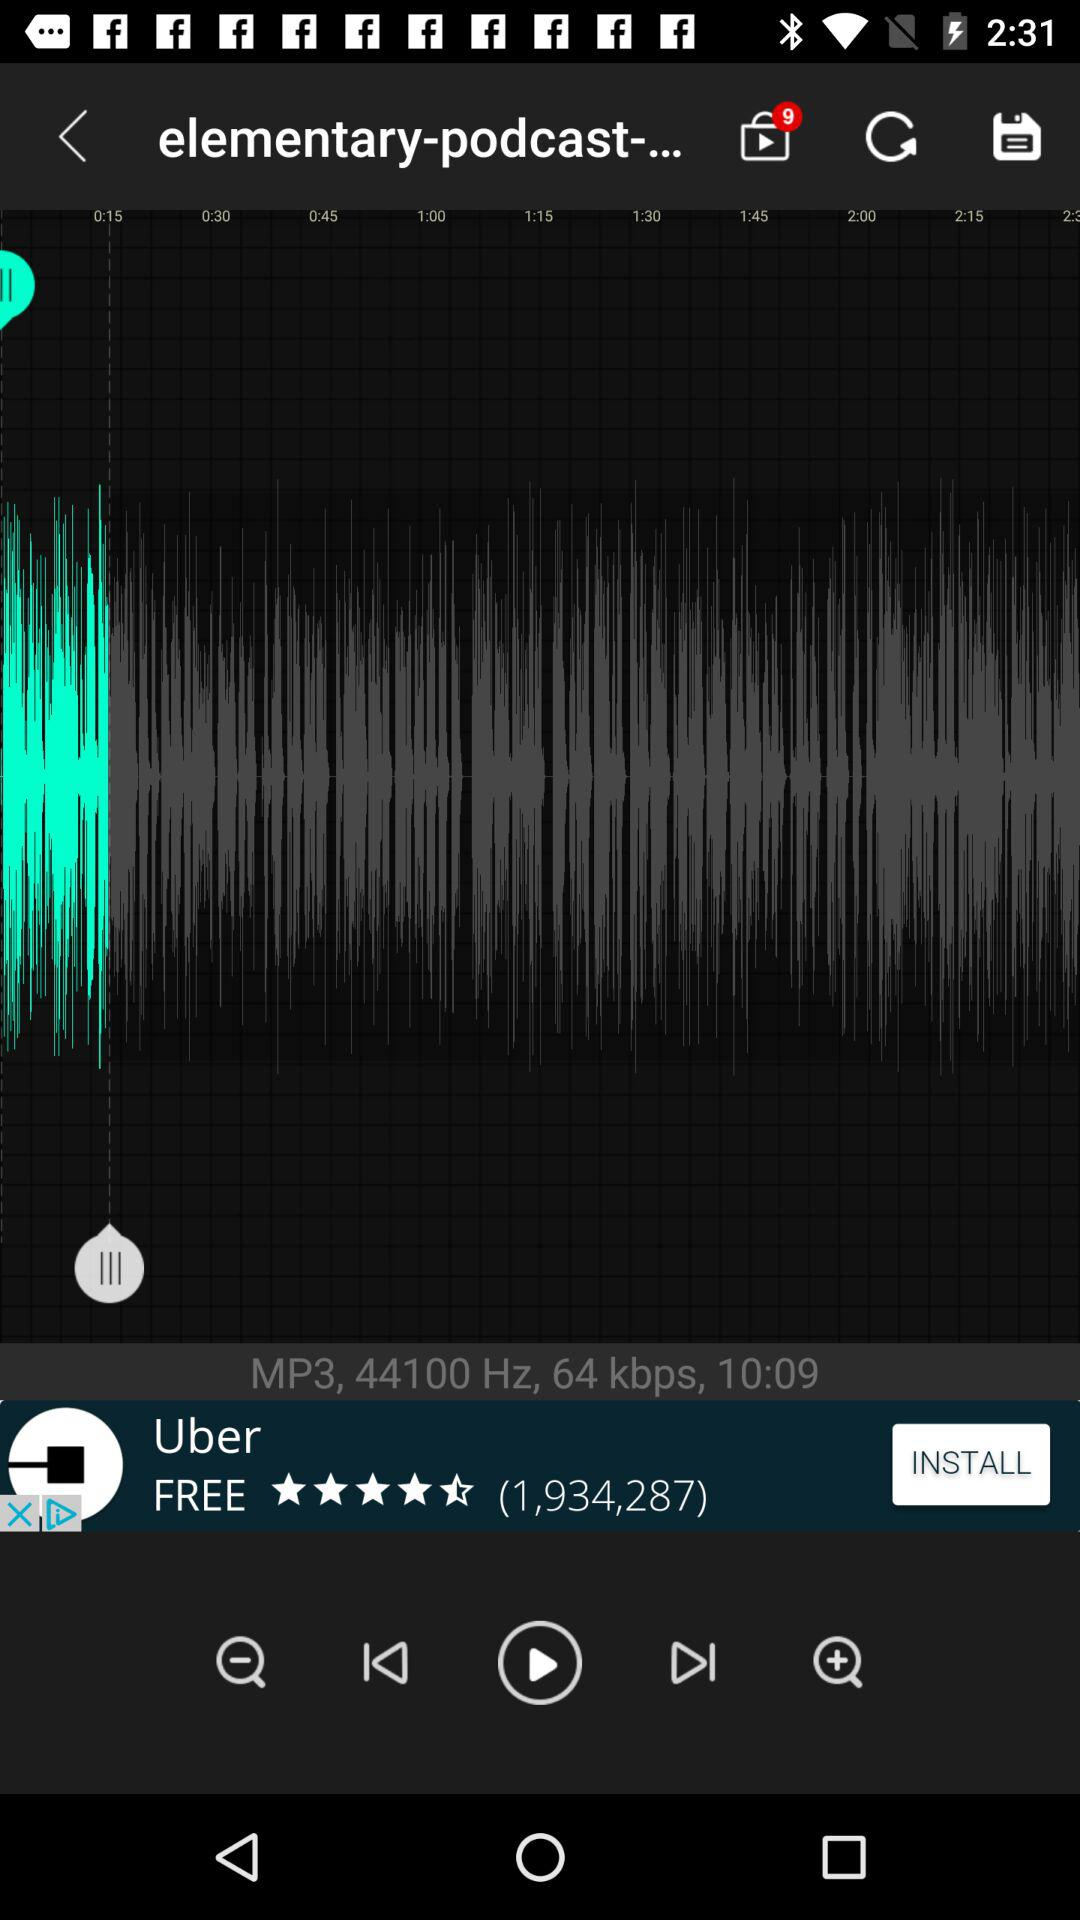What is the time duration? The time duration is 10:09. 